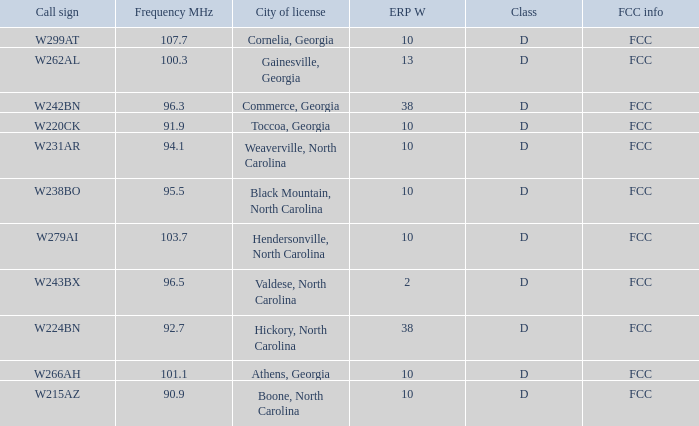What is the FCC frequency for the station w262al which has a Frequency MHz larger than 92.7? FCC. 